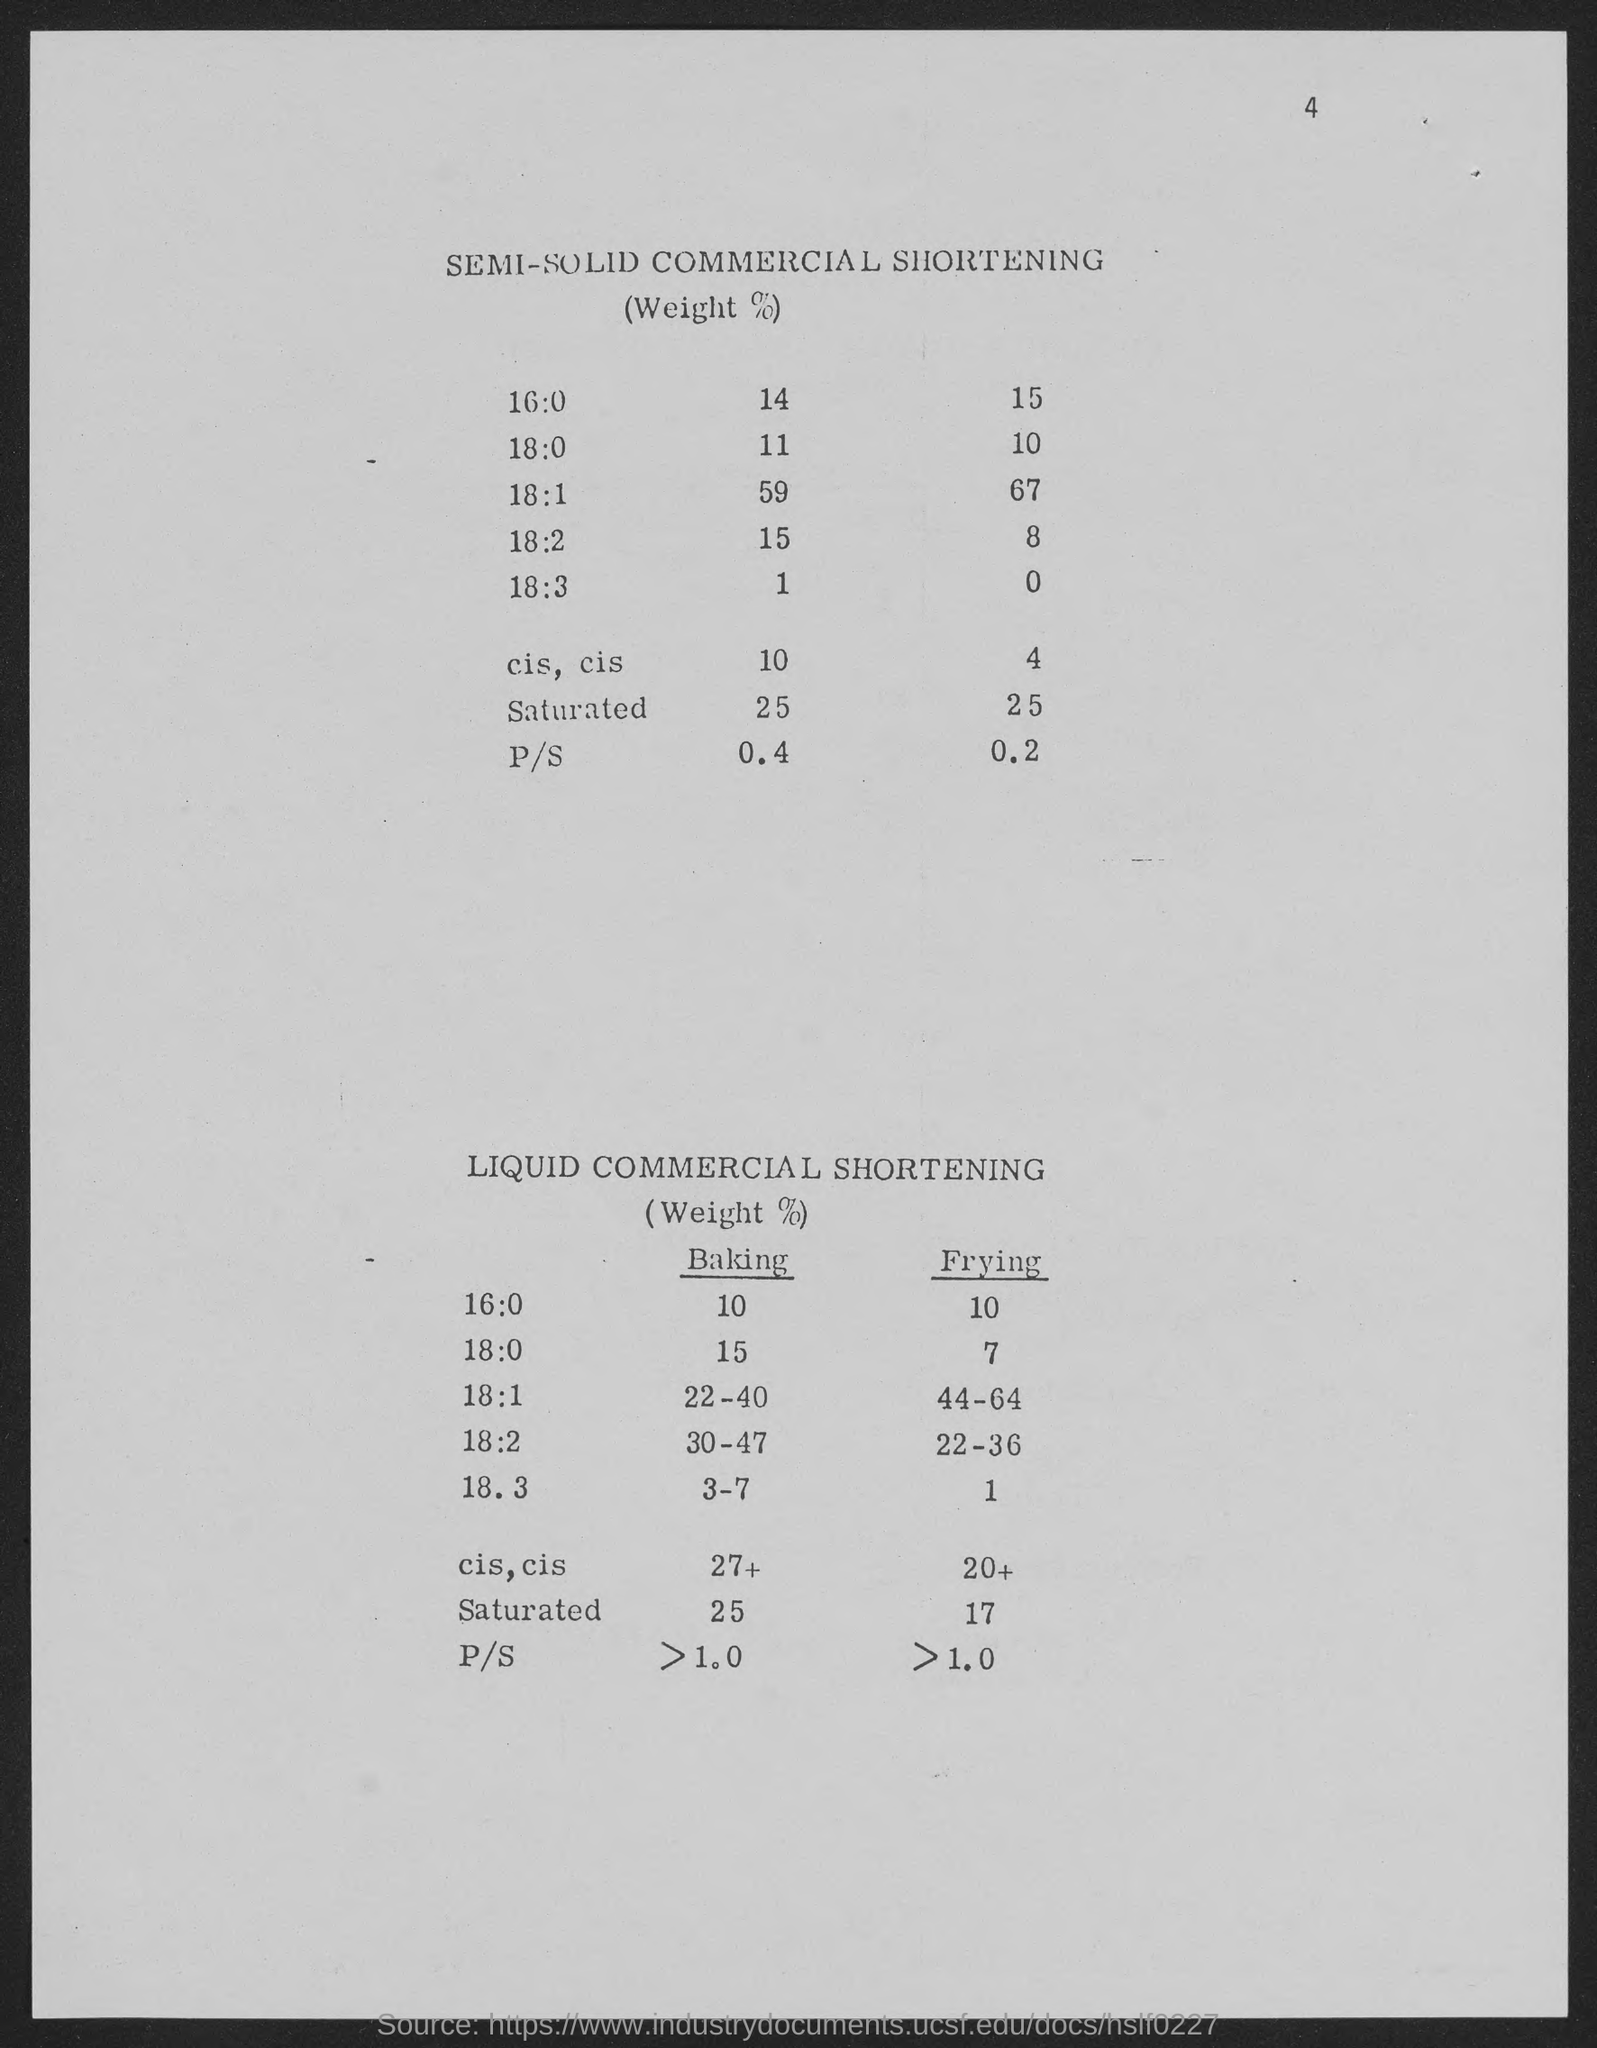What is the number at top-right corner of the page?
Ensure brevity in your answer.  4. 